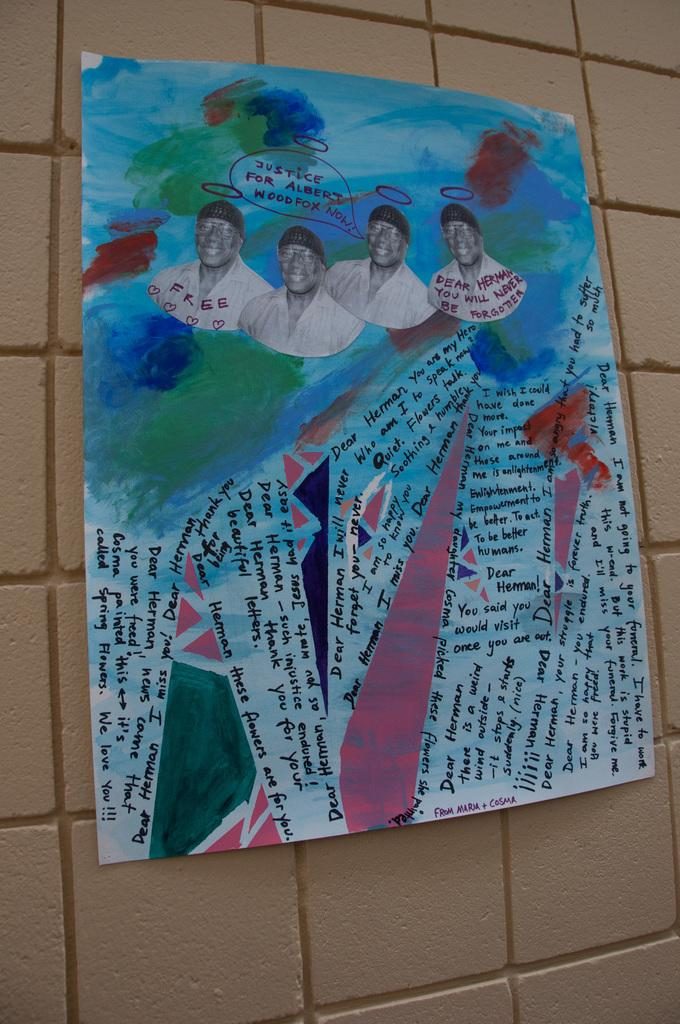What is on the wall in the image? There is a poster on a wall in the image. What is shown on the poster? The poster depicts people. What type of thread is used to create the scarecrow in the image? There is no scarecrow present in the image; the poster depicts people. 